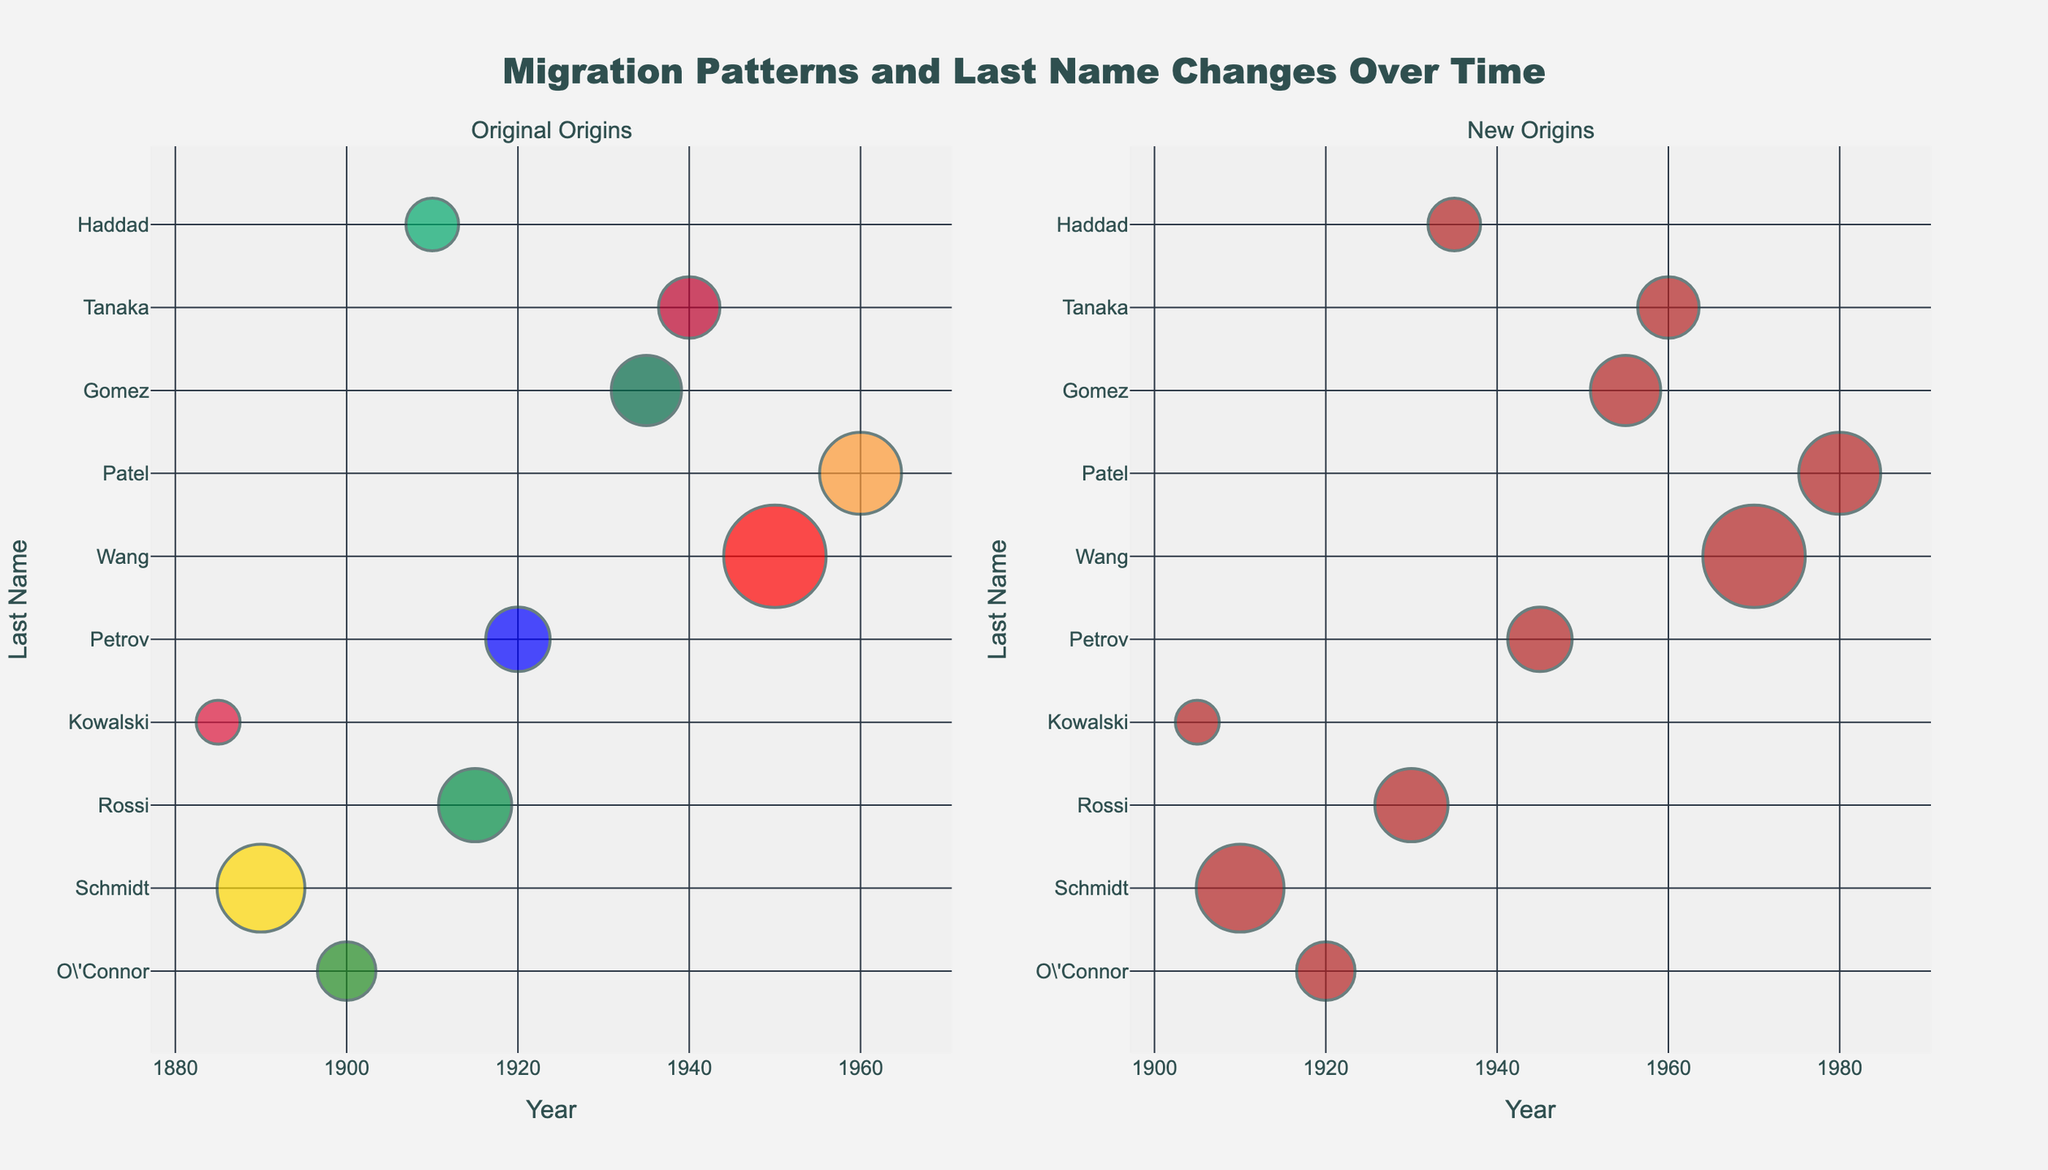what are the title and the two subplot titles in the figure? The title reflects the main subject of the figure, and the subplot titles usually indicate what each subplot represents. According to the subplot_titles argument in the code, the main title is "Migration Patterns and Last Name Changes Over Time", with the two subplot titles being "Original Origins" and "New Origins".
Answer: "Migration Patterns and Last Name Changes Over Time"; "Original Origins"; "New Origins" How many data points are plotted in each subplot? The data points are represented by the rows in the given data. By counting the total number of rows, we determine the total number of data points, which is then reflected in both subplots as each last name has corresponding markers. There are 10 rows, indicating 10 data points in each subplot.
Answer: 10 Which last name has the largest marker size in the new origins subplot? Marker size can be determined from the 'Size' column in the data, and the largest size corresponds to a maximum value. By checking the data, the last name "Wang" has the largest size value of 35, making it the largest marker in the subplot.
Answer: Wang In what year did "Gomez" change their last name? The information about the change year for each last name is provided in the 'ChangeYear' column. By locating "Gomez" and finding the corresponding 'ChangeYear', we see that the year is 1955.
Answer: 1955 Which original origin has the most data points, and how many does it have? Count the occurrences of each value in the 'OriginalOrigin' column to find the origin with the most entries. "American" has the most data points because every last name changes to "American". However, each original origin only appears once in the data.
Answer: Tied (each origin appears once) Compare the average change years of last names with origins "Chinese" and "Italian". Which is earlier? To find the average change year, sum the 'ChangeYear' values for each origin and divide by the number of occurrences. Chinese has a 'ChangeYear' of 1970, while Italian has 1930. Since these origins appear only once, the average years are just 1970 and 1930, respectively. 1930 is earlier.
Answer: Italian What is the relationship between the sizes of the markers for "Rossi" and "Kowalski" in the original origins subplot? By observing the 'Size' column values for "Rossi" and "Kowalski", we determine that "Rossi" has a size of 25 and "Kowalski" has 15. In the subplot, "Rossi" has a larger marker size compared to "Kowalski".
Answer: Rossi's marker is larger What is the median of the OriginYear values for last names starting with "P"? The OriginYear values for "Patel" and "Petrov" are 1960 and 1920, respectively. The median of these two values is the average of them, which is (1960+1920)/2 = 1940.
Answer: 1940 Which country shows the earliest migration pattern according to the original origins data? The earliest migration pattern is determined by the minimum 'OriginYear' value. Looking at the data, "Kowalski" from Poland has the earliest OriginYear, 1885.
Answer: Poland 